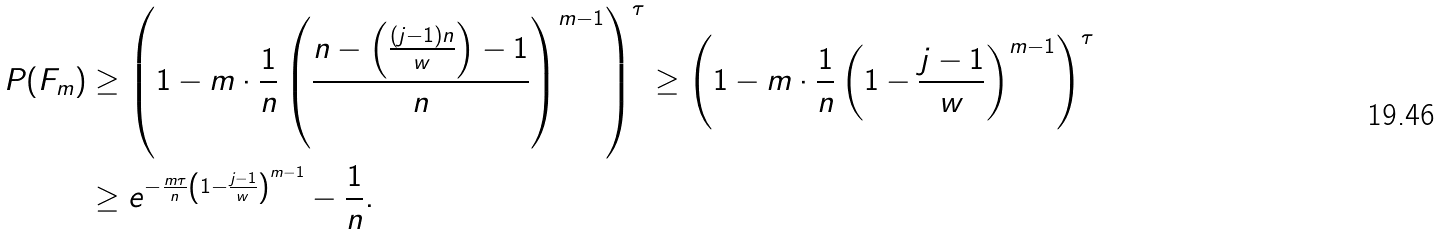<formula> <loc_0><loc_0><loc_500><loc_500>P ( F _ { m } ) & \geq \left ( 1 - m \cdot \frac { 1 } { n } \left ( \frac { n - \left ( \frac { ( j - 1 ) n } { w } \right ) - 1 } { n } \right ) ^ { m - 1 } \right ) ^ { \tau } \geq \left ( 1 - m \cdot \frac { 1 } { n } \left ( 1 - \frac { j - 1 } { w } \right ) ^ { m - 1 } \right ) ^ { \tau } \\ & \geq e ^ { - \frac { m \tau } { n } \left ( 1 - \frac { j - 1 } { w } \right ) ^ { m - 1 } } - \frac { 1 } { n } .</formula> 